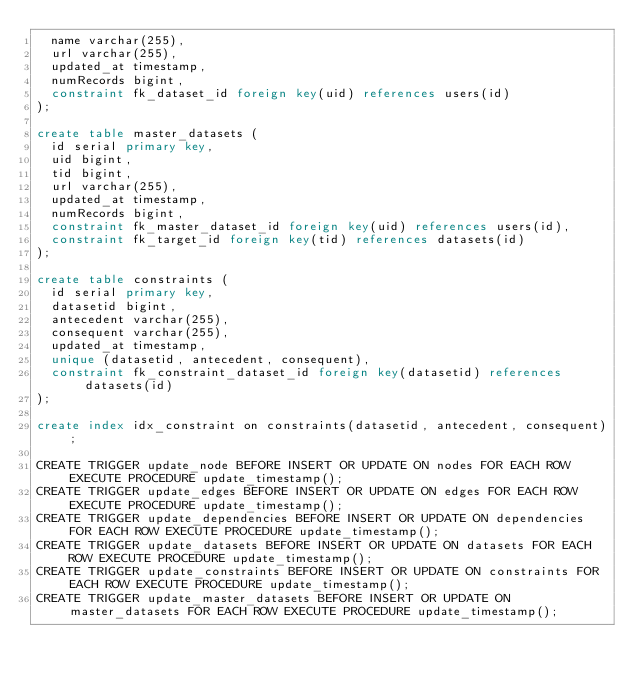Convert code to text. <code><loc_0><loc_0><loc_500><loc_500><_SQL_>	name varchar(255),
	url varchar(255),
	updated_at timestamp,
	numRecords bigint,
	constraint fk_dataset_id foreign key(uid) references users(id)
);

create table master_datasets (
	id serial primary key,
	uid bigint,
	tid bigint,
	url varchar(255),
	updated_at timestamp,
	numRecords bigint,
	constraint fk_master_dataset_id foreign key(uid) references users(id),
	constraint fk_target_id foreign key(tid) references datasets(id)
);

create table constraints (
	id serial primary key,
	datasetid bigint,
	antecedent varchar(255),
	consequent varchar(255),
	updated_at timestamp,
	unique (datasetid, antecedent, consequent),
	constraint fk_constraint_dataset_id foreign key(datasetid) references datasets(id)
);

create index idx_constraint on constraints(datasetid, antecedent, consequent);

CREATE TRIGGER update_node BEFORE INSERT OR UPDATE ON nodes FOR EACH ROW EXECUTE PROCEDURE update_timestamp();
CREATE TRIGGER update_edges BEFORE INSERT OR UPDATE ON edges FOR EACH ROW EXECUTE PROCEDURE update_timestamp();
CREATE TRIGGER update_dependencies BEFORE INSERT OR UPDATE ON dependencies FOR EACH ROW EXECUTE PROCEDURE update_timestamp();
CREATE TRIGGER update_datasets BEFORE INSERT OR UPDATE ON datasets FOR EACH ROW EXECUTE PROCEDURE update_timestamp();
CREATE TRIGGER update_constraints BEFORE INSERT OR UPDATE ON constraints FOR EACH ROW EXECUTE PROCEDURE update_timestamp();
CREATE TRIGGER update_master_datasets BEFORE INSERT OR UPDATE ON master_datasets FOR EACH ROW EXECUTE PROCEDURE update_timestamp();</code> 